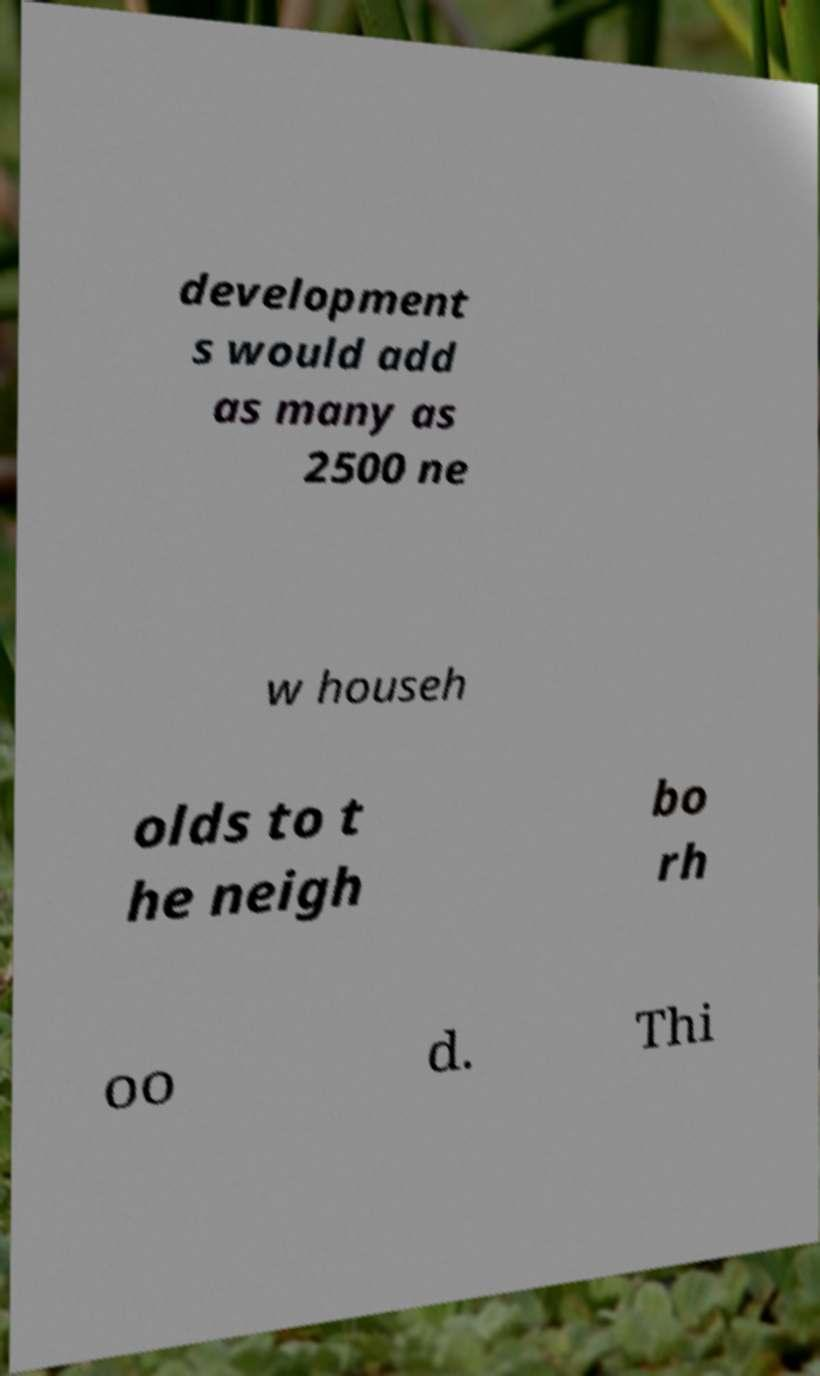Could you extract and type out the text from this image? development s would add as many as 2500 ne w househ olds to t he neigh bo rh oo d. Thi 